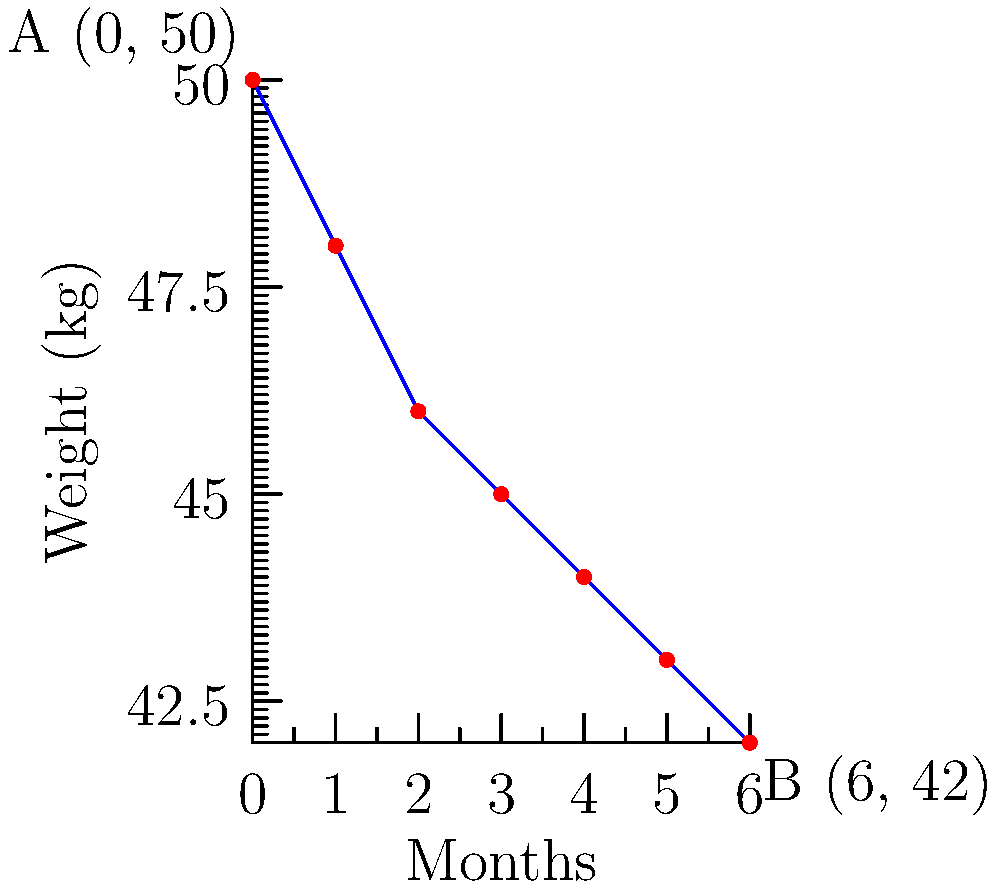A client in eating disorder recovery has been tracking their weight over a period of 6 months. The graph shows their weight change from 50 kg to 42 kg. Calculate the average rate of weight change per month during this period. To find the average rate of weight change per month, we need to calculate the slope of the line connecting points A(0, 50) and B(6, 42).

The slope formula is:
$$ m = \frac{y_2 - y_1}{x_2 - x_1} $$

Where:
$(x_1, y_1)$ is the starting point A(0, 50)
$(x_2, y_2)$ is the ending point B(6, 42)

Plugging in the values:
$$ m = \frac{42 - 50}{6 - 0} = \frac{-8}{6} = -\frac{4}{3} \approx -1.33 $$

The negative sign indicates weight loss.

Therefore, the average rate of weight change is -1.33 kg per month.
Answer: $-\frac{4}{3}$ kg/month or -1.33 kg/month 